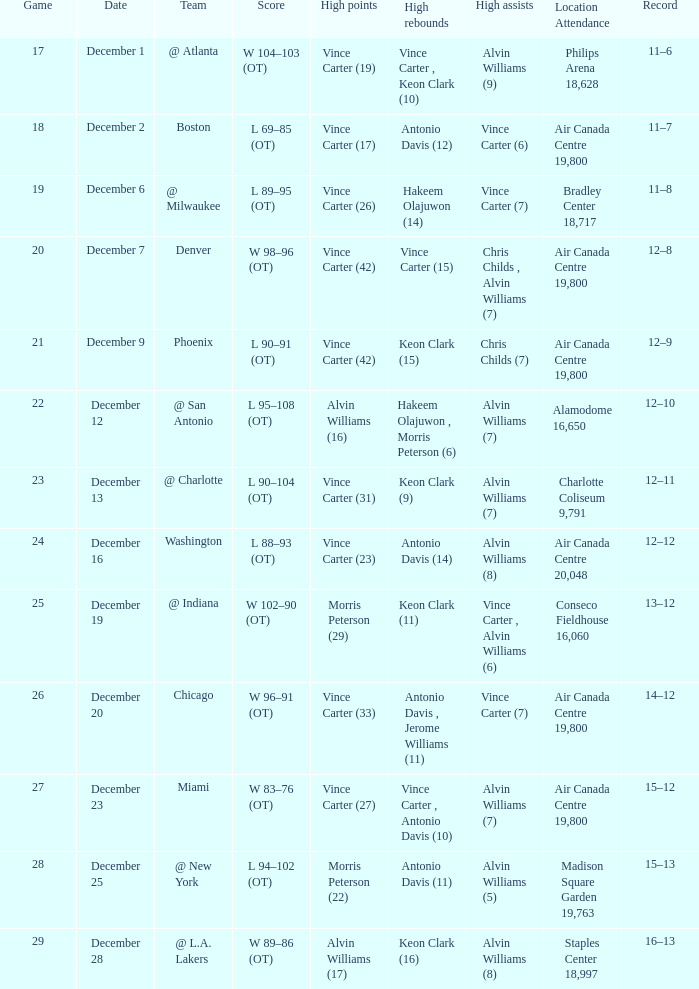Who registered the maximum points against washington? Vince Carter (23). 